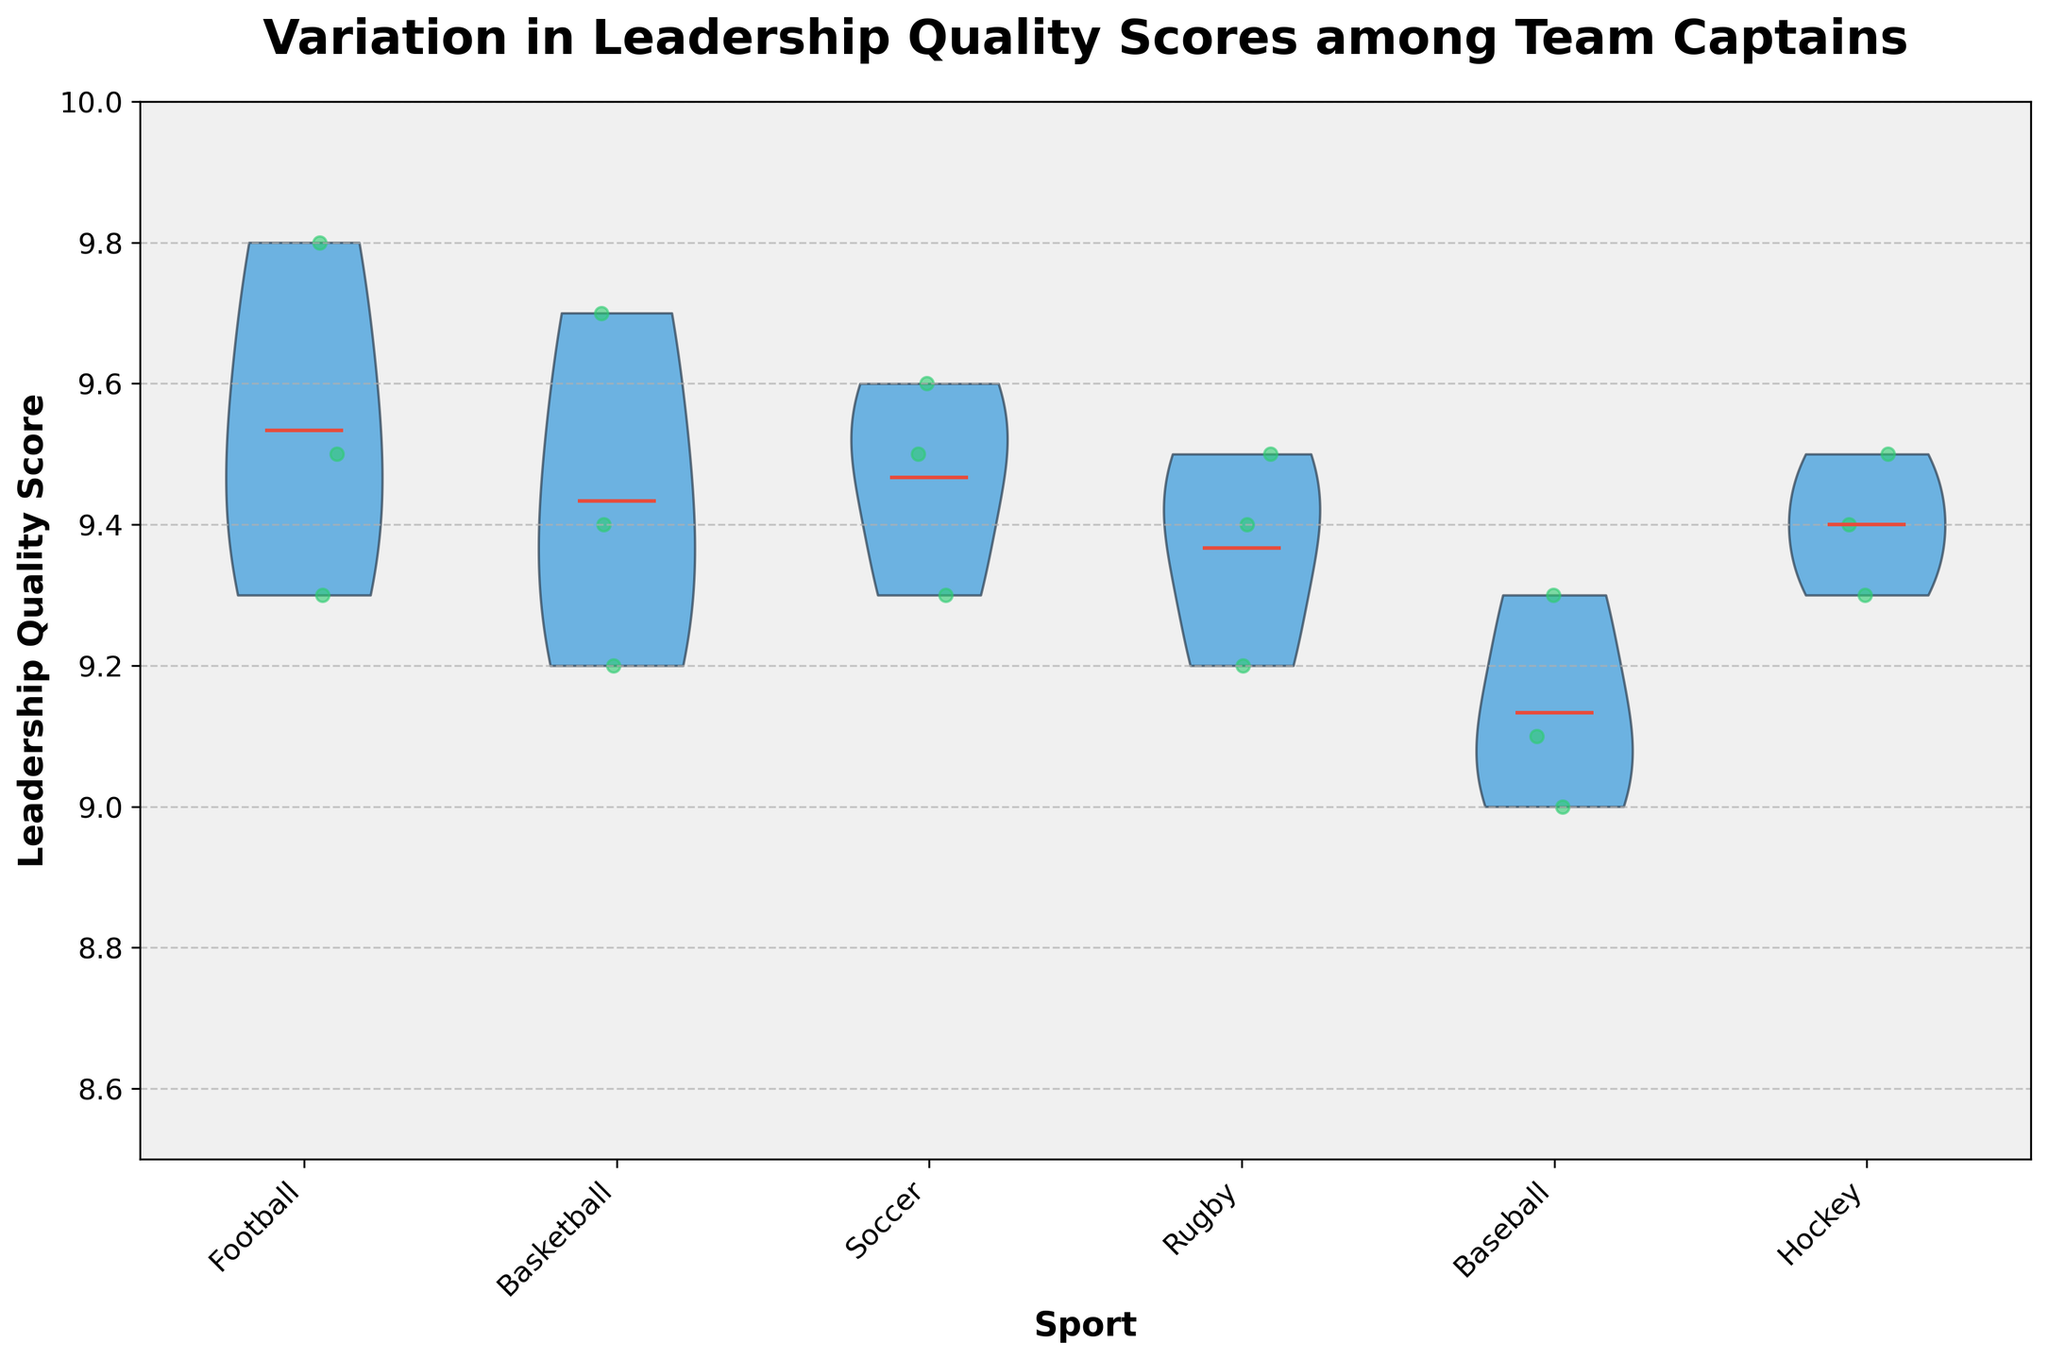What is the title of the figure? The title is located at the top of the figure. It's usually in a larger and bolder font.
Answer: Variation in Leadership Quality Scores among Team Captains Which sport has the highest average leadership quality score? From the violin plot, the means are indicated by a specific marker or color. By comparing these markers across sports, we can see which one is the highest.
Answer: Football What is the range of leadership quality scores for basketball team captains? By looking at the spread of the violin for basketball, we see the lowest and highest points of the distribution.
Answer: 9.2 to 9.7 Are hockey team captains' leadership scores more tightly clustered than football team captains? Tighter clustering is indicated by less spread in the violin plot. Comparing the width of the violins for hockey and football will tell us this information.
Answer: Yes Which sport shows the least variation in leadership quality scores? Least variation will be indicated by the narrowest violin.
Answer: Baseball What is the average leadership quality score for soccer team captains? The mean is marked for each sport in the violin plot, and we should locate the mark for soccer.
Answer: Around 9.5 How do the scores for rugby team captains compare to those for baseball team captains? We compare the spread, mean, and individual points between the two sports by looking at their respective violins.
Answer: Rugby scores are slightly higher and more varied than baseball Are there any outliers in the leadership quality scores for any of the sports? Outliers would be represented by individual dots far from the violin body. By looking at the scatter points, we determine if there are any outliers.
Answer: No Which sport has the broadest range of leadership quality scores? Broadest range is indicated by the widest top-to-bottom spread of the violin.
Answer: Basketball 